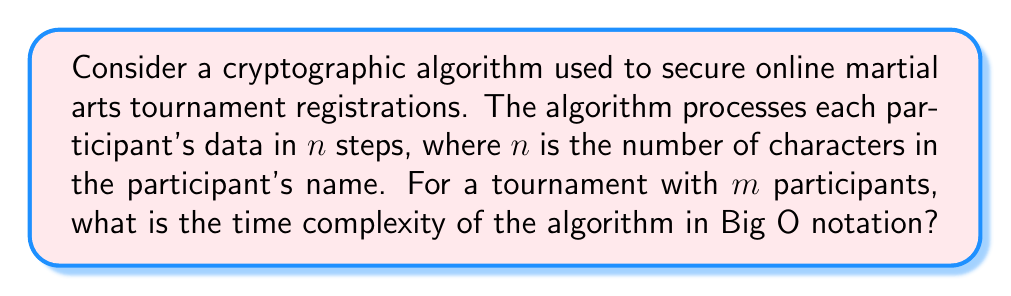Provide a solution to this math problem. Let's approach this step-by-step:

1) First, we need to understand what the algorithm does:
   - It processes each participant's data
   - For each participant, it performs $n$ steps, where $n$ is the length of their name

2) Now, let's consider the total number of operations:
   - For one participant: $n$ operations
   - For $m$ participants: $n_1 + n_2 + ... + n_m$ operations, where $n_i$ is the length of the $i$-th participant's name

3) To simplify, let's assume an average name length of $\bar{n}$:
   - Total operations ≈ $m \cdot \bar{n}$

4) In Big O notation, we're interested in the worst-case scenario as the input size grows:
   - As $m$ (number of participants) increases, the number of operations grows linearly
   - As $\bar{n}$ (average name length) increases, the number of operations also grows linearly

5) The time complexity is the product of these two linear factors:
   $$O(m \cdot \bar{n})$$

6) In Big O notation, we typically express complexity in terms of a single variable. Since both $m$ and $\bar{n}$ could be considered the "size" of the input, we can use $N$ to represent the total input size:
   $$N = m \cdot \bar{n}$$

7) Substituting this back into our time complexity:
   $$O(N)$$

Thus, the time complexity of the algorithm is linear with respect to the total input size.
Answer: $O(N)$ 